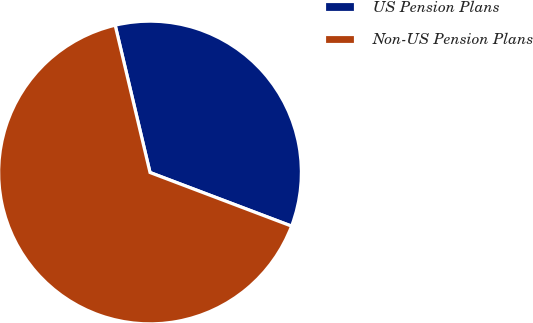Convert chart. <chart><loc_0><loc_0><loc_500><loc_500><pie_chart><fcel>US Pension Plans<fcel>Non-US Pension Plans<nl><fcel>34.46%<fcel>65.54%<nl></chart> 